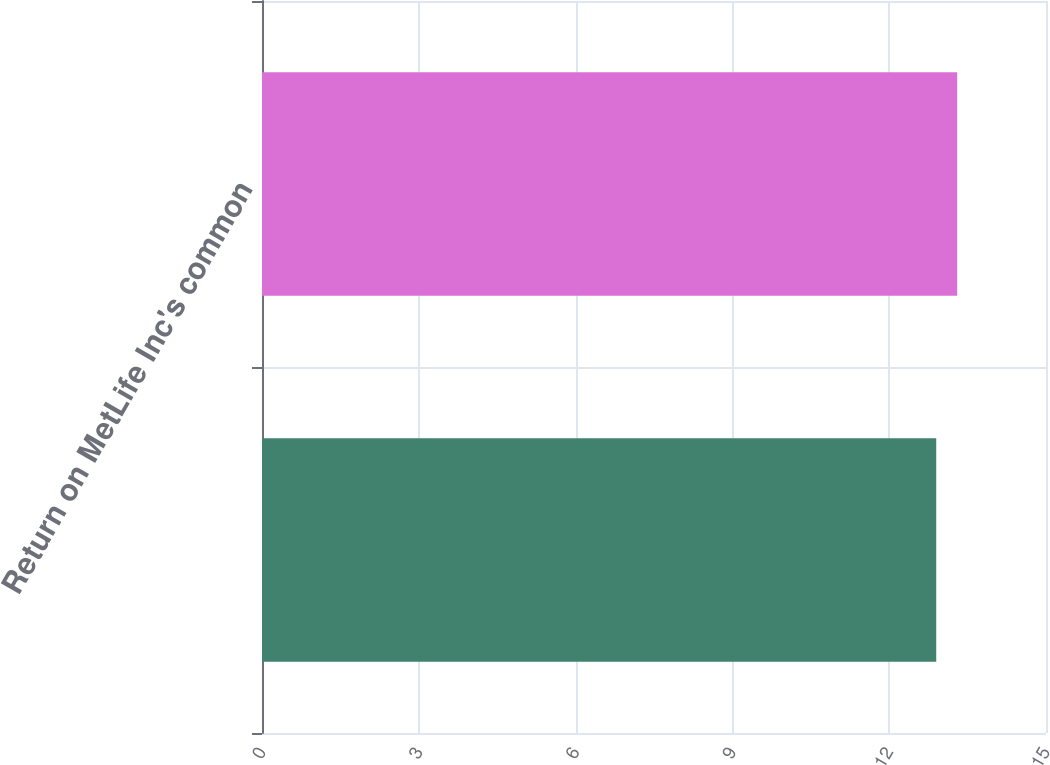Convert chart to OTSL. <chart><loc_0><loc_0><loc_500><loc_500><bar_chart><ecel><fcel>Return on MetLife Inc's common<nl><fcel>12.9<fcel>13.3<nl></chart> 